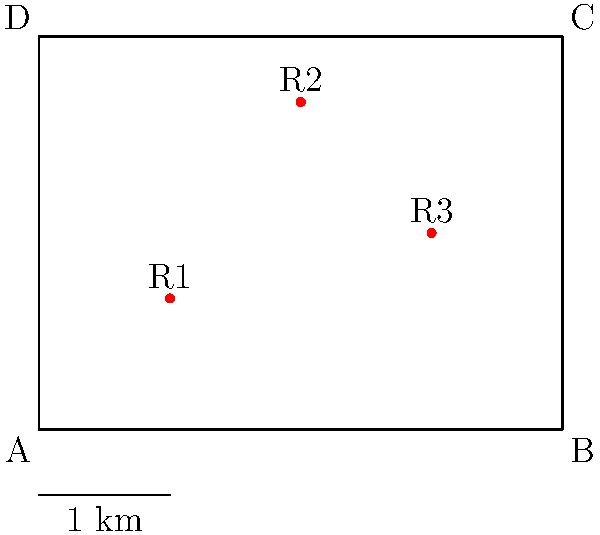In the disputed territory ABCD, three key resources (R1, R2, R3) are located as shown. If negotiations require dividing the territory into two equal areas while ensuring fair access to resources, which line would be the most suitable division? Explain your reasoning considering both area equality and resource distribution. To solve this problem, we need to consider both equal area division and fair resource distribution:

1. Equal area division:
   - The territory is a 4x3 rectangle, so its total area is 12 square units.
   - To divide it into two equal areas, we need a line that creates two 6 square unit areas.

2. Possible division lines:
   a) Vertical line at x = 2: This divides the area equally (2 * 3 = 6 for each side).
   b) Horizontal line at y = 1.5: This also divides the area equally (4 * 1.5 = 6 for each side).
   c) Diagonal line from (0, 0) to (4, 3): This divides the area equally as well.

3. Resource distribution:
   - R1 is located at (1, 1)
   - R2 is located at (2, 2.5)
   - R3 is located at (3, 1.5)

4. Analyzing each division option:
   a) Vertical line at x = 2:
      - Left side: R1
      - Right side: R2, R3
   b) Horizontal line at y = 1.5:
      - Bottom: R1, R3
      - Top: R2
   c) Diagonal line:
      - Lower-left: R1
      - Upper-right: R2, R3

5. Conclusion:
   The horizontal line at y = 1.5 provides the most balanced distribution of resources (2:1) while maintaining equal areas. It allows each side to have access to resources and provides a clear, easily demarcated border.
Answer: Horizontal line at y = 1.5 